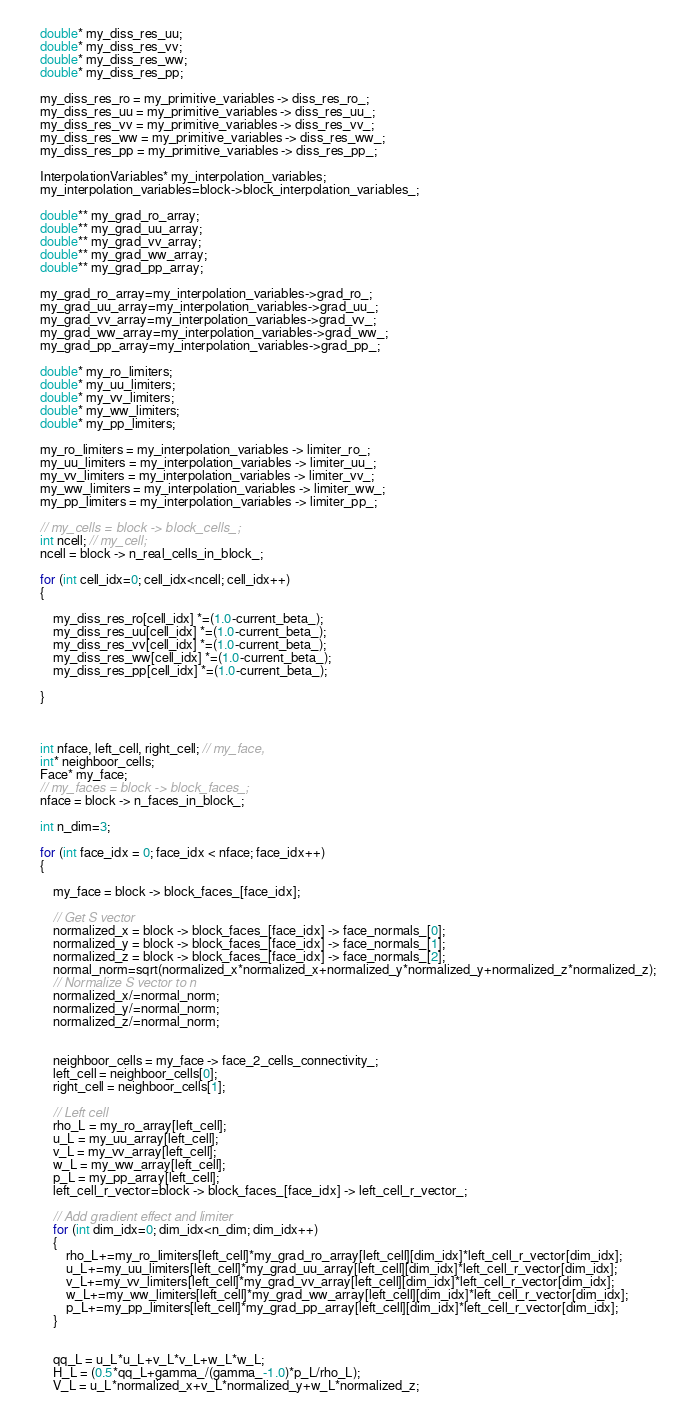<code> <loc_0><loc_0><loc_500><loc_500><_C++_>	double* my_diss_res_uu;
	double* my_diss_res_vv;
	double* my_diss_res_ww;
	double* my_diss_res_pp;

	my_diss_res_ro = my_primitive_variables -> diss_res_ro_;
	my_diss_res_uu = my_primitive_variables -> diss_res_uu_;
	my_diss_res_vv = my_primitive_variables -> diss_res_vv_;
	my_diss_res_ww = my_primitive_variables -> diss_res_ww_;
	my_diss_res_pp = my_primitive_variables -> diss_res_pp_;

	InterpolationVariables* my_interpolation_variables;
	my_interpolation_variables=block->block_interpolation_variables_;

	double** my_grad_ro_array;
	double** my_grad_uu_array;
	double** my_grad_vv_array;
	double** my_grad_ww_array;
	double** my_grad_pp_array;

	my_grad_ro_array=my_interpolation_variables->grad_ro_;
	my_grad_uu_array=my_interpolation_variables->grad_uu_;
	my_grad_vv_array=my_interpolation_variables->grad_vv_;
	my_grad_ww_array=my_interpolation_variables->grad_ww_;
	my_grad_pp_array=my_interpolation_variables->grad_pp_;

	double* my_ro_limiters;
	double* my_uu_limiters;
	double* my_vv_limiters;
	double* my_ww_limiters;
	double* my_pp_limiters;

	my_ro_limiters = my_interpolation_variables -> limiter_ro_;
	my_uu_limiters = my_interpolation_variables -> limiter_uu_;
	my_vv_limiters = my_interpolation_variables -> limiter_vv_;
	my_ww_limiters = my_interpolation_variables -> limiter_ww_;
	my_pp_limiters = my_interpolation_variables -> limiter_pp_;

	// my_cells = block -> block_cells_;
	int ncell; // my_cell;
	ncell = block -> n_real_cells_in_block_;
	
	for (int cell_idx=0; cell_idx<ncell; cell_idx++)
	{
		
		my_diss_res_ro[cell_idx] *=(1.0-current_beta_);
		my_diss_res_uu[cell_idx] *=(1.0-current_beta_);
		my_diss_res_vv[cell_idx] *=(1.0-current_beta_);
		my_diss_res_ww[cell_idx] *=(1.0-current_beta_);
		my_diss_res_pp[cell_idx] *=(1.0-current_beta_);

	}
	
	

	int nface, left_cell, right_cell; // my_face,
	int* neighboor_cells;
	Face* my_face;
	// my_faces = block -> block_faces_;
	nface = block -> n_faces_in_block_;

	int n_dim=3;

	for (int face_idx = 0; face_idx < nface; face_idx++)
	{

		my_face = block -> block_faces_[face_idx];

		// Get S vector
		normalized_x = block -> block_faces_[face_idx] -> face_normals_[0];
		normalized_y = block -> block_faces_[face_idx] -> face_normals_[1];
		normalized_z = block -> block_faces_[face_idx] -> face_normals_[2];
		normal_norm=sqrt(normalized_x*normalized_x+normalized_y*normalized_y+normalized_z*normalized_z);
		// Normalize S vector to n
		normalized_x/=normal_norm;
		normalized_y/=normal_norm;
		normalized_z/=normal_norm;


		neighboor_cells = my_face -> face_2_cells_connectivity_;
		left_cell = neighboor_cells[0];
		right_cell = neighboor_cells[1];

		// Left cell
		rho_L = my_ro_array[left_cell];
		u_L = my_uu_array[left_cell];
		v_L = my_vv_array[left_cell];
		w_L = my_ww_array[left_cell];
		p_L = my_pp_array[left_cell];
		left_cell_r_vector=block -> block_faces_[face_idx] -> left_cell_r_vector_;

		// Add gradient effect and limiter
		for (int dim_idx=0; dim_idx<n_dim; dim_idx++)
		{
			rho_L+=my_ro_limiters[left_cell]*my_grad_ro_array[left_cell][dim_idx]*left_cell_r_vector[dim_idx];
			u_L+=my_uu_limiters[left_cell]*my_grad_uu_array[left_cell][dim_idx]*left_cell_r_vector[dim_idx];
			v_L+=my_vv_limiters[left_cell]*my_grad_vv_array[left_cell][dim_idx]*left_cell_r_vector[dim_idx];
			w_L+=my_ww_limiters[left_cell]*my_grad_ww_array[left_cell][dim_idx]*left_cell_r_vector[dim_idx];
			p_L+=my_pp_limiters[left_cell]*my_grad_pp_array[left_cell][dim_idx]*left_cell_r_vector[dim_idx];
		}
		

		qq_L = u_L*u_L+v_L*v_L+w_L*w_L;
		H_L = (0.5*qq_L+gamma_/(gamma_-1.0)*p_L/rho_L);
		V_L = u_L*normalized_x+v_L*normalized_y+w_L*normalized_z;
</code> 